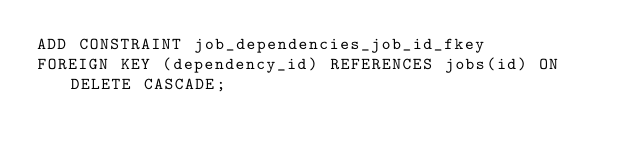Convert code to text. <code><loc_0><loc_0><loc_500><loc_500><_SQL_>ADD CONSTRAINT job_dependencies_job_id_fkey
FOREIGN KEY (dependency_id) REFERENCES jobs(id) ON DELETE CASCADE;
</code> 